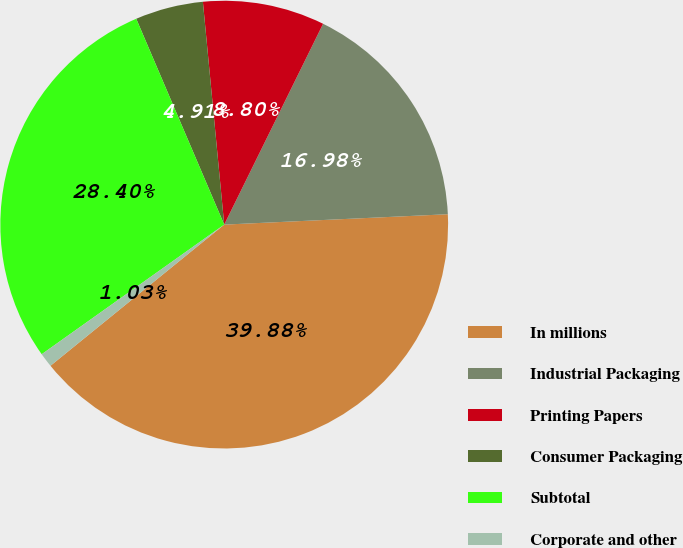Convert chart to OTSL. <chart><loc_0><loc_0><loc_500><loc_500><pie_chart><fcel>In millions<fcel>Industrial Packaging<fcel>Printing Papers<fcel>Consumer Packaging<fcel>Subtotal<fcel>Corporate and other<nl><fcel>39.88%<fcel>16.98%<fcel>8.8%<fcel>4.91%<fcel>28.4%<fcel>1.03%<nl></chart> 